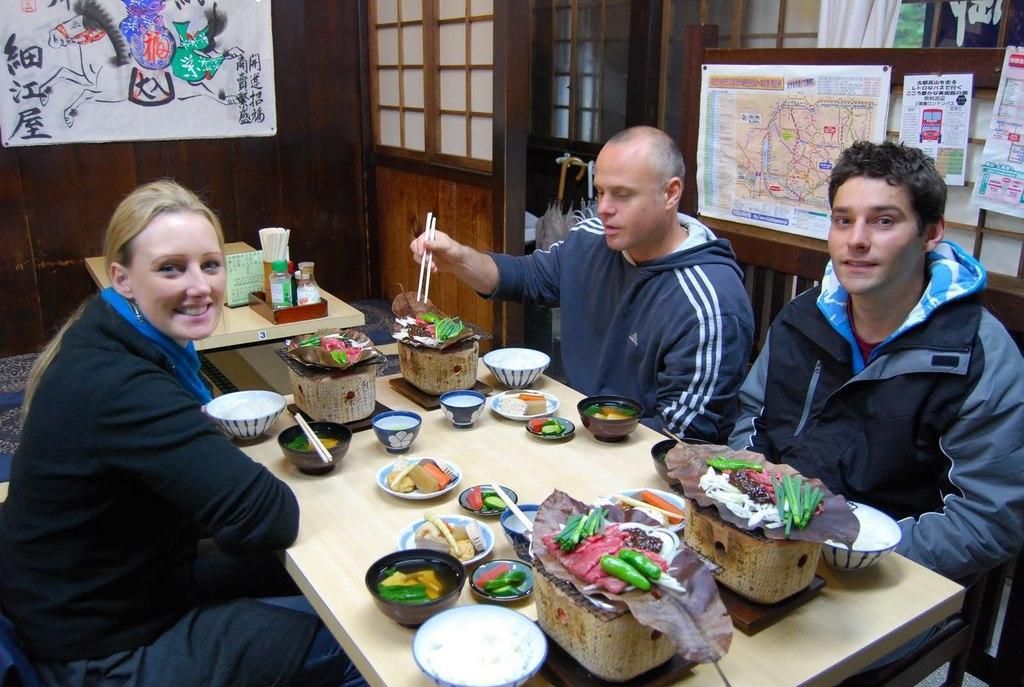Please provide a concise description of this image. In this picture I can see there are three people sitting at the table, there are few bowls placed on the table and the person here is holding the chop sticks and there are photo frames and posters attached to the wall and there is a door in the backdrop. 